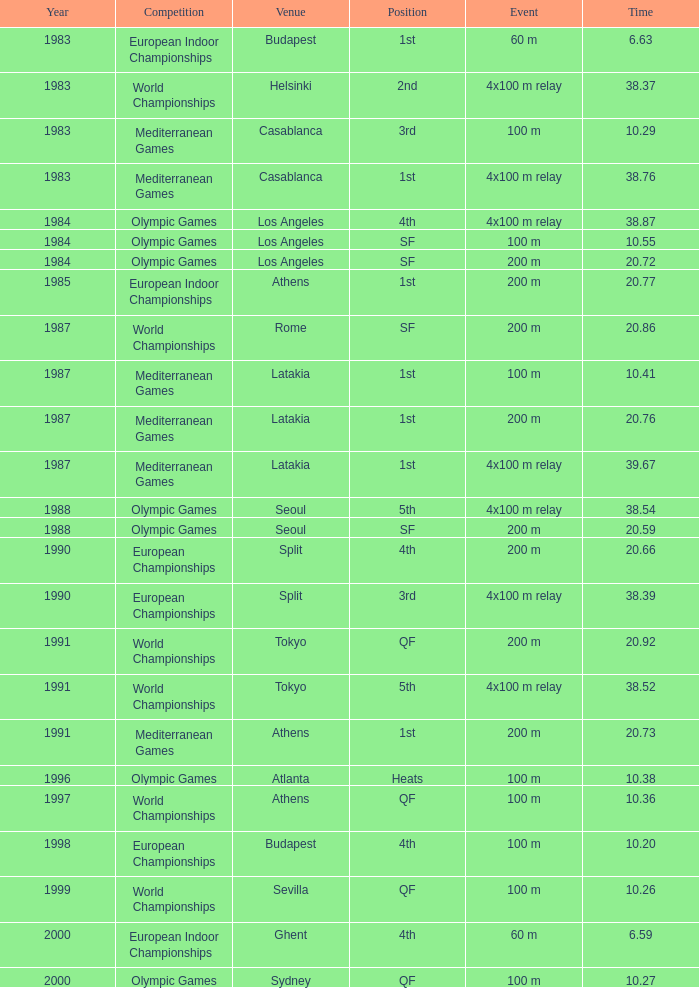29, contest of mediterranean games, and occurrence of 4x100 m relay? Casablanca, Latakia. 